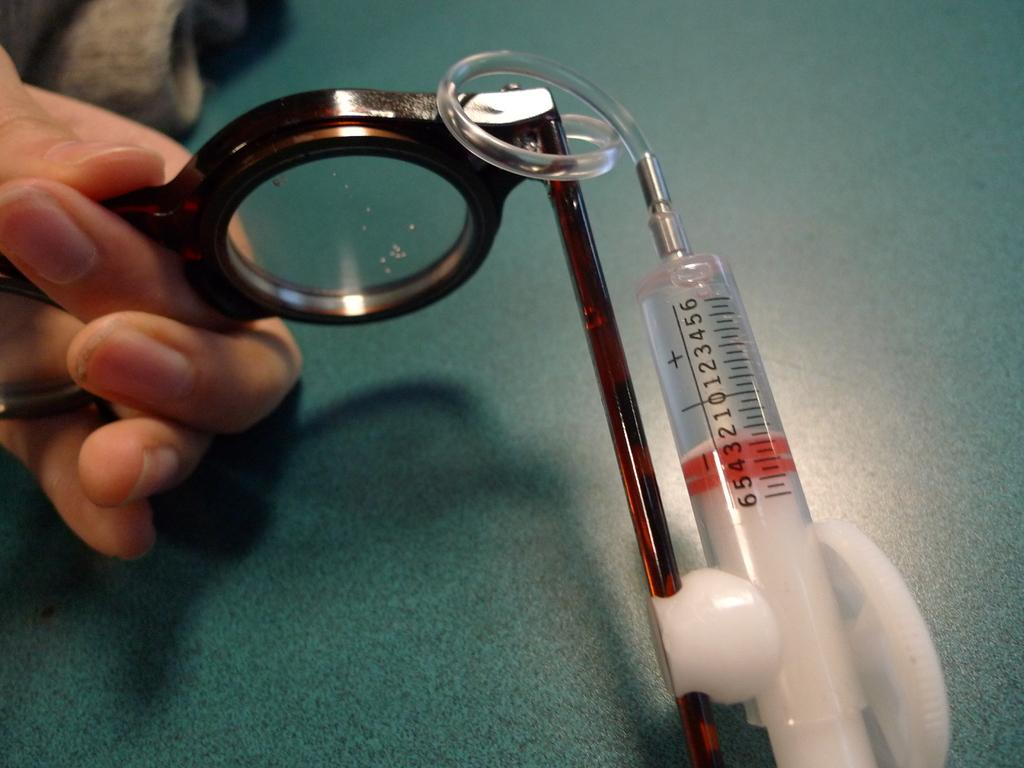<image>
Write a terse but informative summary of the picture. A case filled with red fluid in it and numbers on it. 